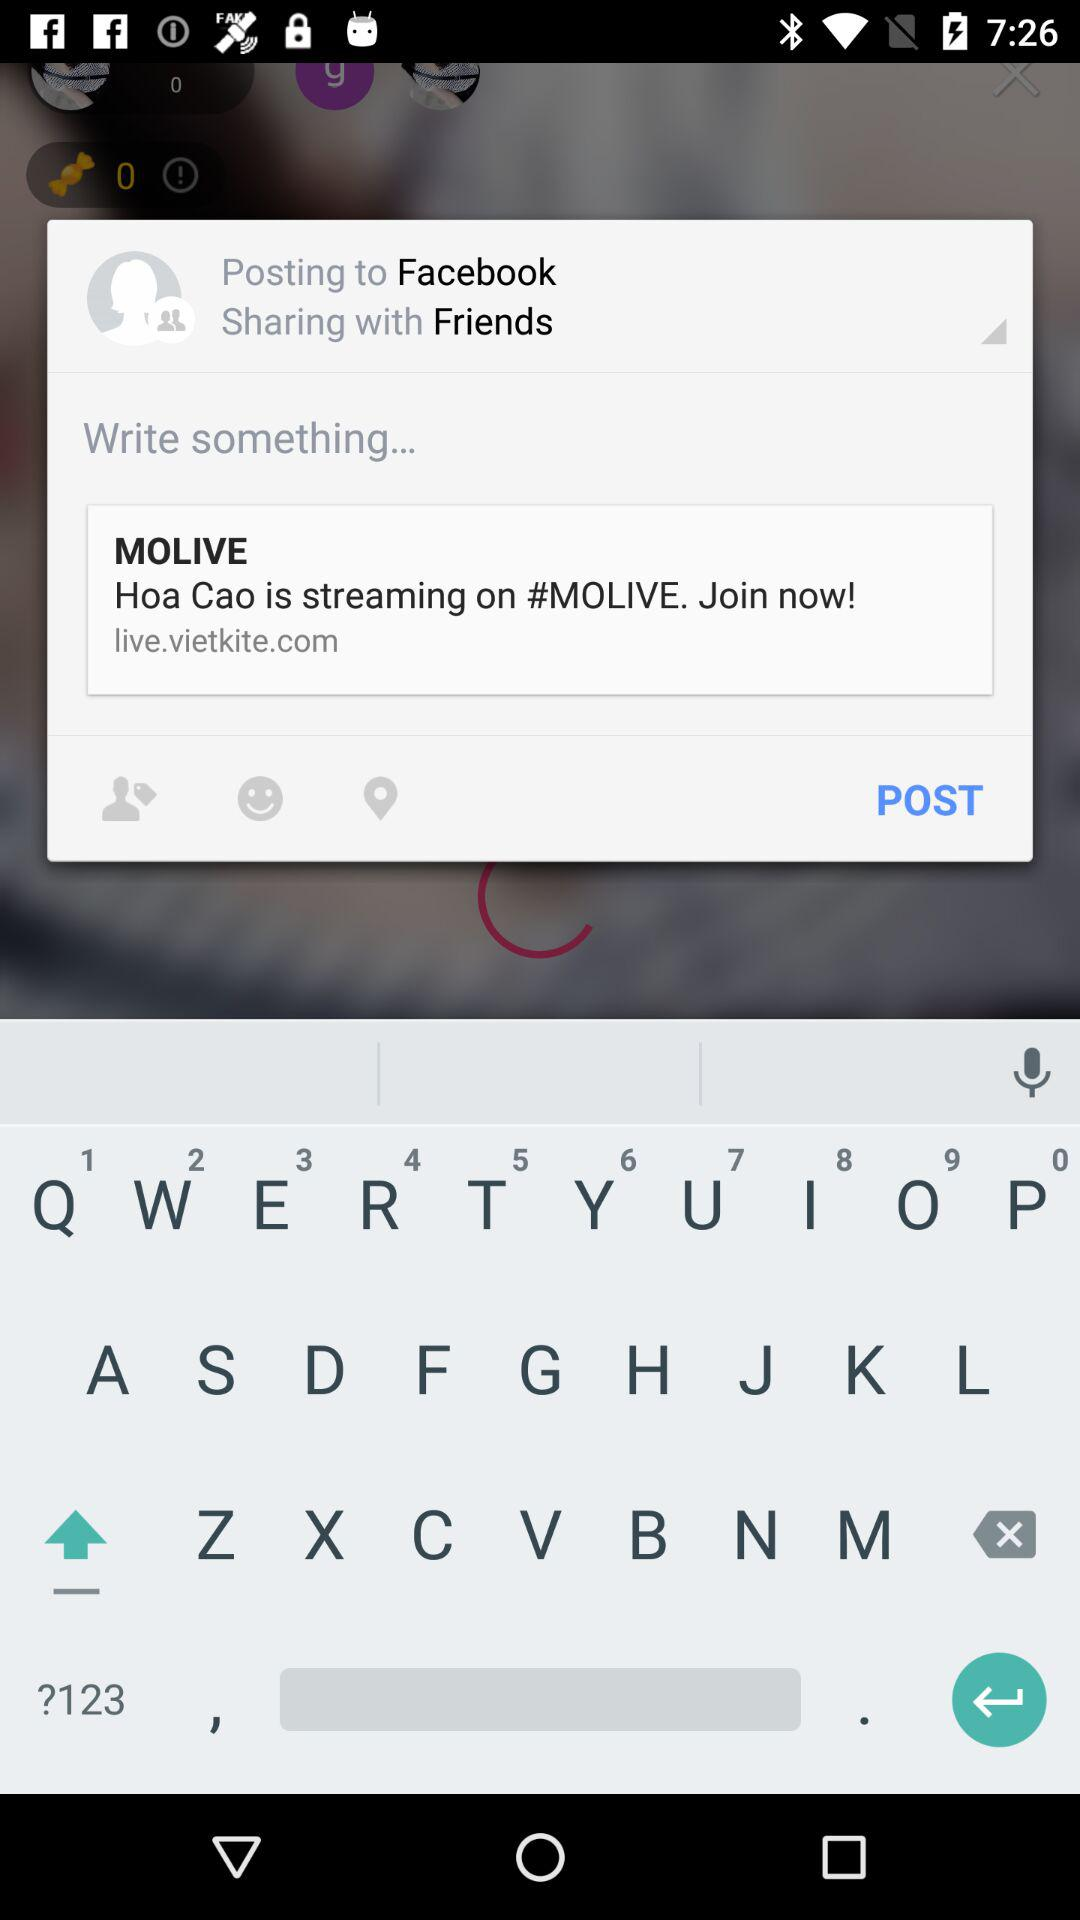What application is asking for permission? The application is "MoLive". 